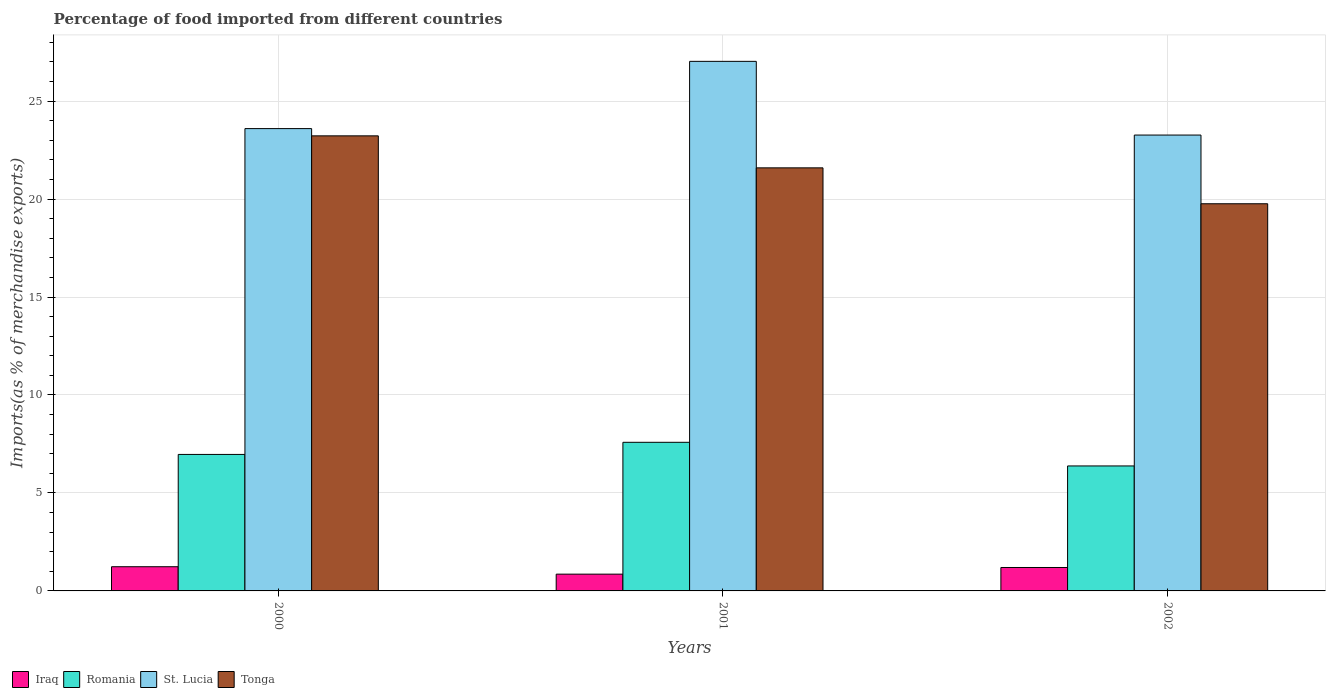How many different coloured bars are there?
Provide a succinct answer. 4. How many groups of bars are there?
Ensure brevity in your answer.  3. Are the number of bars per tick equal to the number of legend labels?
Your answer should be compact. Yes. What is the percentage of imports to different countries in Iraq in 2001?
Make the answer very short. 0.86. Across all years, what is the maximum percentage of imports to different countries in Iraq?
Give a very brief answer. 1.23. Across all years, what is the minimum percentage of imports to different countries in St. Lucia?
Provide a short and direct response. 23.27. In which year was the percentage of imports to different countries in Iraq minimum?
Ensure brevity in your answer.  2001. What is the total percentage of imports to different countries in St. Lucia in the graph?
Keep it short and to the point. 73.89. What is the difference between the percentage of imports to different countries in Iraq in 2000 and that in 2001?
Offer a very short reply. 0.38. What is the difference between the percentage of imports to different countries in Iraq in 2000 and the percentage of imports to different countries in St. Lucia in 2001?
Your response must be concise. -25.79. What is the average percentage of imports to different countries in St. Lucia per year?
Your answer should be compact. 24.63. In the year 2002, what is the difference between the percentage of imports to different countries in St. Lucia and percentage of imports to different countries in Romania?
Offer a terse response. 16.89. In how many years, is the percentage of imports to different countries in Tonga greater than 13 %?
Ensure brevity in your answer.  3. What is the ratio of the percentage of imports to different countries in Tonga in 2000 to that in 2001?
Your response must be concise. 1.08. What is the difference between the highest and the second highest percentage of imports to different countries in Iraq?
Offer a terse response. 0.04. What is the difference between the highest and the lowest percentage of imports to different countries in Tonga?
Your response must be concise. 3.47. In how many years, is the percentage of imports to different countries in St. Lucia greater than the average percentage of imports to different countries in St. Lucia taken over all years?
Your response must be concise. 1. Is it the case that in every year, the sum of the percentage of imports to different countries in Iraq and percentage of imports to different countries in St. Lucia is greater than the sum of percentage of imports to different countries in Romania and percentage of imports to different countries in Tonga?
Your answer should be compact. Yes. What does the 1st bar from the left in 2000 represents?
Offer a terse response. Iraq. What does the 3rd bar from the right in 2002 represents?
Keep it short and to the point. Romania. How many bars are there?
Give a very brief answer. 12. Are all the bars in the graph horizontal?
Ensure brevity in your answer.  No. Are the values on the major ticks of Y-axis written in scientific E-notation?
Keep it short and to the point. No. Does the graph contain any zero values?
Offer a terse response. No. Where does the legend appear in the graph?
Offer a terse response. Bottom left. How are the legend labels stacked?
Keep it short and to the point. Horizontal. What is the title of the graph?
Provide a short and direct response. Percentage of food imported from different countries. What is the label or title of the X-axis?
Provide a short and direct response. Years. What is the label or title of the Y-axis?
Ensure brevity in your answer.  Imports(as % of merchandise exports). What is the Imports(as % of merchandise exports) of Iraq in 2000?
Your answer should be compact. 1.23. What is the Imports(as % of merchandise exports) of Romania in 2000?
Provide a short and direct response. 6.97. What is the Imports(as % of merchandise exports) of St. Lucia in 2000?
Keep it short and to the point. 23.6. What is the Imports(as % of merchandise exports) of Tonga in 2000?
Provide a succinct answer. 23.23. What is the Imports(as % of merchandise exports) of Iraq in 2001?
Keep it short and to the point. 0.86. What is the Imports(as % of merchandise exports) in Romania in 2001?
Your response must be concise. 7.59. What is the Imports(as % of merchandise exports) in St. Lucia in 2001?
Provide a short and direct response. 27.03. What is the Imports(as % of merchandise exports) in Tonga in 2001?
Make the answer very short. 21.59. What is the Imports(as % of merchandise exports) of Iraq in 2002?
Your response must be concise. 1.2. What is the Imports(as % of merchandise exports) of Romania in 2002?
Ensure brevity in your answer.  6.38. What is the Imports(as % of merchandise exports) of St. Lucia in 2002?
Keep it short and to the point. 23.27. What is the Imports(as % of merchandise exports) in Tonga in 2002?
Make the answer very short. 19.76. Across all years, what is the maximum Imports(as % of merchandise exports) in Iraq?
Make the answer very short. 1.23. Across all years, what is the maximum Imports(as % of merchandise exports) of Romania?
Provide a succinct answer. 7.59. Across all years, what is the maximum Imports(as % of merchandise exports) in St. Lucia?
Keep it short and to the point. 27.03. Across all years, what is the maximum Imports(as % of merchandise exports) of Tonga?
Ensure brevity in your answer.  23.23. Across all years, what is the minimum Imports(as % of merchandise exports) of Iraq?
Your answer should be compact. 0.86. Across all years, what is the minimum Imports(as % of merchandise exports) of Romania?
Ensure brevity in your answer.  6.38. Across all years, what is the minimum Imports(as % of merchandise exports) in St. Lucia?
Provide a succinct answer. 23.27. Across all years, what is the minimum Imports(as % of merchandise exports) in Tonga?
Offer a terse response. 19.76. What is the total Imports(as % of merchandise exports) of Iraq in the graph?
Make the answer very short. 3.29. What is the total Imports(as % of merchandise exports) of Romania in the graph?
Make the answer very short. 20.93. What is the total Imports(as % of merchandise exports) in St. Lucia in the graph?
Offer a very short reply. 73.89. What is the total Imports(as % of merchandise exports) in Tonga in the graph?
Your answer should be compact. 64.58. What is the difference between the Imports(as % of merchandise exports) in Iraq in 2000 and that in 2001?
Offer a very short reply. 0.38. What is the difference between the Imports(as % of merchandise exports) of Romania in 2000 and that in 2001?
Ensure brevity in your answer.  -0.62. What is the difference between the Imports(as % of merchandise exports) of St. Lucia in 2000 and that in 2001?
Ensure brevity in your answer.  -3.43. What is the difference between the Imports(as % of merchandise exports) in Tonga in 2000 and that in 2001?
Offer a very short reply. 1.63. What is the difference between the Imports(as % of merchandise exports) in Iraq in 2000 and that in 2002?
Provide a succinct answer. 0.04. What is the difference between the Imports(as % of merchandise exports) of Romania in 2000 and that in 2002?
Offer a very short reply. 0.59. What is the difference between the Imports(as % of merchandise exports) in St. Lucia in 2000 and that in 2002?
Offer a very short reply. 0.33. What is the difference between the Imports(as % of merchandise exports) in Tonga in 2000 and that in 2002?
Your answer should be very brief. 3.47. What is the difference between the Imports(as % of merchandise exports) of Iraq in 2001 and that in 2002?
Your response must be concise. -0.34. What is the difference between the Imports(as % of merchandise exports) of Romania in 2001 and that in 2002?
Keep it short and to the point. 1.21. What is the difference between the Imports(as % of merchandise exports) of St. Lucia in 2001 and that in 2002?
Offer a very short reply. 3.76. What is the difference between the Imports(as % of merchandise exports) in Tonga in 2001 and that in 2002?
Keep it short and to the point. 1.83. What is the difference between the Imports(as % of merchandise exports) in Iraq in 2000 and the Imports(as % of merchandise exports) in Romania in 2001?
Provide a succinct answer. -6.35. What is the difference between the Imports(as % of merchandise exports) of Iraq in 2000 and the Imports(as % of merchandise exports) of St. Lucia in 2001?
Ensure brevity in your answer.  -25.79. What is the difference between the Imports(as % of merchandise exports) in Iraq in 2000 and the Imports(as % of merchandise exports) in Tonga in 2001?
Provide a short and direct response. -20.36. What is the difference between the Imports(as % of merchandise exports) of Romania in 2000 and the Imports(as % of merchandise exports) of St. Lucia in 2001?
Offer a terse response. -20.06. What is the difference between the Imports(as % of merchandise exports) of Romania in 2000 and the Imports(as % of merchandise exports) of Tonga in 2001?
Your response must be concise. -14.63. What is the difference between the Imports(as % of merchandise exports) of St. Lucia in 2000 and the Imports(as % of merchandise exports) of Tonga in 2001?
Give a very brief answer. 2. What is the difference between the Imports(as % of merchandise exports) of Iraq in 2000 and the Imports(as % of merchandise exports) of Romania in 2002?
Provide a short and direct response. -5.14. What is the difference between the Imports(as % of merchandise exports) of Iraq in 2000 and the Imports(as % of merchandise exports) of St. Lucia in 2002?
Your answer should be very brief. -22.03. What is the difference between the Imports(as % of merchandise exports) of Iraq in 2000 and the Imports(as % of merchandise exports) of Tonga in 2002?
Your answer should be very brief. -18.53. What is the difference between the Imports(as % of merchandise exports) in Romania in 2000 and the Imports(as % of merchandise exports) in St. Lucia in 2002?
Provide a succinct answer. -16.3. What is the difference between the Imports(as % of merchandise exports) of Romania in 2000 and the Imports(as % of merchandise exports) of Tonga in 2002?
Keep it short and to the point. -12.79. What is the difference between the Imports(as % of merchandise exports) in St. Lucia in 2000 and the Imports(as % of merchandise exports) in Tonga in 2002?
Ensure brevity in your answer.  3.84. What is the difference between the Imports(as % of merchandise exports) in Iraq in 2001 and the Imports(as % of merchandise exports) in Romania in 2002?
Your answer should be very brief. -5.52. What is the difference between the Imports(as % of merchandise exports) in Iraq in 2001 and the Imports(as % of merchandise exports) in St. Lucia in 2002?
Offer a very short reply. -22.41. What is the difference between the Imports(as % of merchandise exports) in Iraq in 2001 and the Imports(as % of merchandise exports) in Tonga in 2002?
Your response must be concise. -18.9. What is the difference between the Imports(as % of merchandise exports) in Romania in 2001 and the Imports(as % of merchandise exports) in St. Lucia in 2002?
Provide a succinct answer. -15.68. What is the difference between the Imports(as % of merchandise exports) in Romania in 2001 and the Imports(as % of merchandise exports) in Tonga in 2002?
Ensure brevity in your answer.  -12.18. What is the difference between the Imports(as % of merchandise exports) in St. Lucia in 2001 and the Imports(as % of merchandise exports) in Tonga in 2002?
Your answer should be compact. 7.27. What is the average Imports(as % of merchandise exports) in Iraq per year?
Your response must be concise. 1.1. What is the average Imports(as % of merchandise exports) of Romania per year?
Give a very brief answer. 6.98. What is the average Imports(as % of merchandise exports) of St. Lucia per year?
Keep it short and to the point. 24.63. What is the average Imports(as % of merchandise exports) of Tonga per year?
Ensure brevity in your answer.  21.53. In the year 2000, what is the difference between the Imports(as % of merchandise exports) of Iraq and Imports(as % of merchandise exports) of Romania?
Offer a very short reply. -5.73. In the year 2000, what is the difference between the Imports(as % of merchandise exports) in Iraq and Imports(as % of merchandise exports) in St. Lucia?
Ensure brevity in your answer.  -22.36. In the year 2000, what is the difference between the Imports(as % of merchandise exports) in Iraq and Imports(as % of merchandise exports) in Tonga?
Ensure brevity in your answer.  -21.99. In the year 2000, what is the difference between the Imports(as % of merchandise exports) in Romania and Imports(as % of merchandise exports) in St. Lucia?
Keep it short and to the point. -16.63. In the year 2000, what is the difference between the Imports(as % of merchandise exports) of Romania and Imports(as % of merchandise exports) of Tonga?
Give a very brief answer. -16.26. In the year 2000, what is the difference between the Imports(as % of merchandise exports) in St. Lucia and Imports(as % of merchandise exports) in Tonga?
Offer a terse response. 0.37. In the year 2001, what is the difference between the Imports(as % of merchandise exports) in Iraq and Imports(as % of merchandise exports) in Romania?
Offer a very short reply. -6.73. In the year 2001, what is the difference between the Imports(as % of merchandise exports) in Iraq and Imports(as % of merchandise exports) in St. Lucia?
Give a very brief answer. -26.17. In the year 2001, what is the difference between the Imports(as % of merchandise exports) of Iraq and Imports(as % of merchandise exports) of Tonga?
Keep it short and to the point. -20.74. In the year 2001, what is the difference between the Imports(as % of merchandise exports) in Romania and Imports(as % of merchandise exports) in St. Lucia?
Offer a very short reply. -19.44. In the year 2001, what is the difference between the Imports(as % of merchandise exports) of Romania and Imports(as % of merchandise exports) of Tonga?
Give a very brief answer. -14.01. In the year 2001, what is the difference between the Imports(as % of merchandise exports) in St. Lucia and Imports(as % of merchandise exports) in Tonga?
Your answer should be very brief. 5.44. In the year 2002, what is the difference between the Imports(as % of merchandise exports) of Iraq and Imports(as % of merchandise exports) of Romania?
Make the answer very short. -5.18. In the year 2002, what is the difference between the Imports(as % of merchandise exports) of Iraq and Imports(as % of merchandise exports) of St. Lucia?
Keep it short and to the point. -22.07. In the year 2002, what is the difference between the Imports(as % of merchandise exports) in Iraq and Imports(as % of merchandise exports) in Tonga?
Offer a terse response. -18.57. In the year 2002, what is the difference between the Imports(as % of merchandise exports) in Romania and Imports(as % of merchandise exports) in St. Lucia?
Provide a short and direct response. -16.89. In the year 2002, what is the difference between the Imports(as % of merchandise exports) of Romania and Imports(as % of merchandise exports) of Tonga?
Ensure brevity in your answer.  -13.38. In the year 2002, what is the difference between the Imports(as % of merchandise exports) of St. Lucia and Imports(as % of merchandise exports) of Tonga?
Your answer should be compact. 3.51. What is the ratio of the Imports(as % of merchandise exports) of Iraq in 2000 to that in 2001?
Offer a terse response. 1.44. What is the ratio of the Imports(as % of merchandise exports) in Romania in 2000 to that in 2001?
Give a very brief answer. 0.92. What is the ratio of the Imports(as % of merchandise exports) of St. Lucia in 2000 to that in 2001?
Your answer should be very brief. 0.87. What is the ratio of the Imports(as % of merchandise exports) in Tonga in 2000 to that in 2001?
Ensure brevity in your answer.  1.08. What is the ratio of the Imports(as % of merchandise exports) of Iraq in 2000 to that in 2002?
Your response must be concise. 1.03. What is the ratio of the Imports(as % of merchandise exports) in Romania in 2000 to that in 2002?
Your answer should be compact. 1.09. What is the ratio of the Imports(as % of merchandise exports) of St. Lucia in 2000 to that in 2002?
Your answer should be very brief. 1.01. What is the ratio of the Imports(as % of merchandise exports) in Tonga in 2000 to that in 2002?
Provide a short and direct response. 1.18. What is the ratio of the Imports(as % of merchandise exports) in Iraq in 2001 to that in 2002?
Keep it short and to the point. 0.72. What is the ratio of the Imports(as % of merchandise exports) of Romania in 2001 to that in 2002?
Your answer should be compact. 1.19. What is the ratio of the Imports(as % of merchandise exports) of St. Lucia in 2001 to that in 2002?
Your answer should be compact. 1.16. What is the ratio of the Imports(as % of merchandise exports) of Tonga in 2001 to that in 2002?
Your answer should be very brief. 1.09. What is the difference between the highest and the second highest Imports(as % of merchandise exports) of Iraq?
Your answer should be very brief. 0.04. What is the difference between the highest and the second highest Imports(as % of merchandise exports) of Romania?
Make the answer very short. 0.62. What is the difference between the highest and the second highest Imports(as % of merchandise exports) in St. Lucia?
Offer a very short reply. 3.43. What is the difference between the highest and the second highest Imports(as % of merchandise exports) in Tonga?
Offer a terse response. 1.63. What is the difference between the highest and the lowest Imports(as % of merchandise exports) in Iraq?
Make the answer very short. 0.38. What is the difference between the highest and the lowest Imports(as % of merchandise exports) of Romania?
Keep it short and to the point. 1.21. What is the difference between the highest and the lowest Imports(as % of merchandise exports) in St. Lucia?
Your answer should be very brief. 3.76. What is the difference between the highest and the lowest Imports(as % of merchandise exports) in Tonga?
Offer a very short reply. 3.47. 